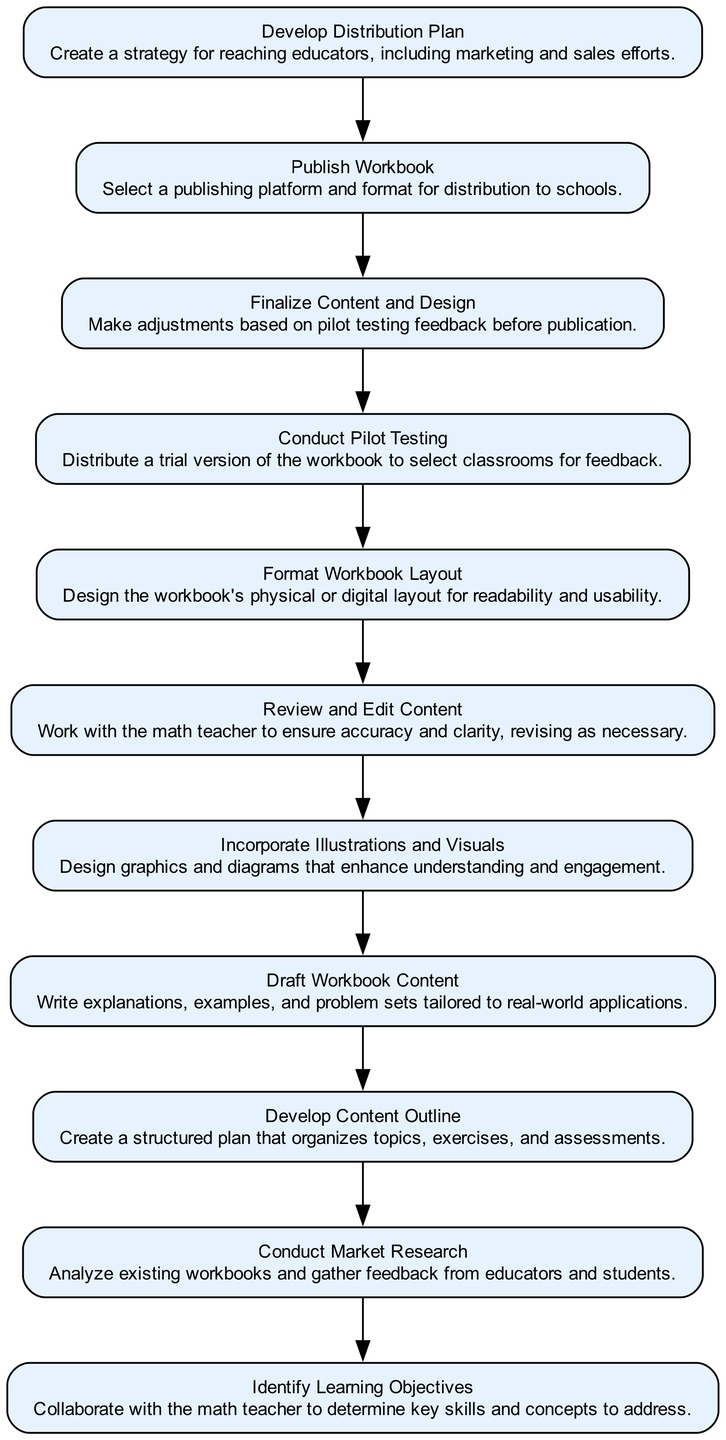What is the first step in the flow chart? The flow chart begins with "Identify Learning Objectives," indicating it is the starting point of the design process.
Answer: Identify Learning Objectives How many steps are involved in the process? By counting the elements listed in the dataset, there are a total of 11 steps from conceptualization to publishing.
Answer: 11 Which step comes after "Draft Workbook Content"? The step following "Draft Workbook Content" is "Incorporate Illustrations and Visuals," which builds upon the drafted content.
Answer: Incorporate Illustrations and Visuals What is the last step in the flow chart? The final step listed in the flow chart is "Develop Distribution Plan," which completes the design process.
Answer: Develop Distribution Plan What step is directly linked to "Conduct Market Research"? The step that directly follows "Conduct Market Research" is "Develop Content Outline," making it the next part of the workflow.
Answer: Develop Content Outline What step involves gathering feedback from classrooms? "Conduct Pilot Testing" involves distributing a trial version of the workbook to selected classrooms to gather feedback.
Answer: Conduct Pilot Testing Which two steps focus on the content review process? The two steps focusing on the content review are "Review and Edit Content" and "Finalize Content and Design," both crucial for ensuring quality.
Answer: Review and Edit Content; Finalize Content and Design Which step is concerned with the publishing of the workbook? "Publish Workbook" is the step dedicated to the actual publishing process, indicating it involves making the workbook available.
Answer: Publish Workbook What is the relationship between "Conduct Market Research" and "Draft Workbook Content"? "Conduct Market Research" is an earlier step in the process, and its findings inform "Draft Workbook Content," demonstrating a dependency between them.
Answer: Inform What is emphasized in the "Incorporate Illustrations and Visuals" step? This step emphasizes enhancing understanding and engagement through the use of graphics and diagrams in the workbook.
Answer: Graphics and diagrams 